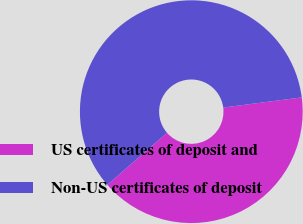Convert chart to OTSL. <chart><loc_0><loc_0><loc_500><loc_500><pie_chart><fcel>US certificates of deposit and<fcel>Non-US certificates of deposit<nl><fcel>40.64%<fcel>59.36%<nl></chart> 